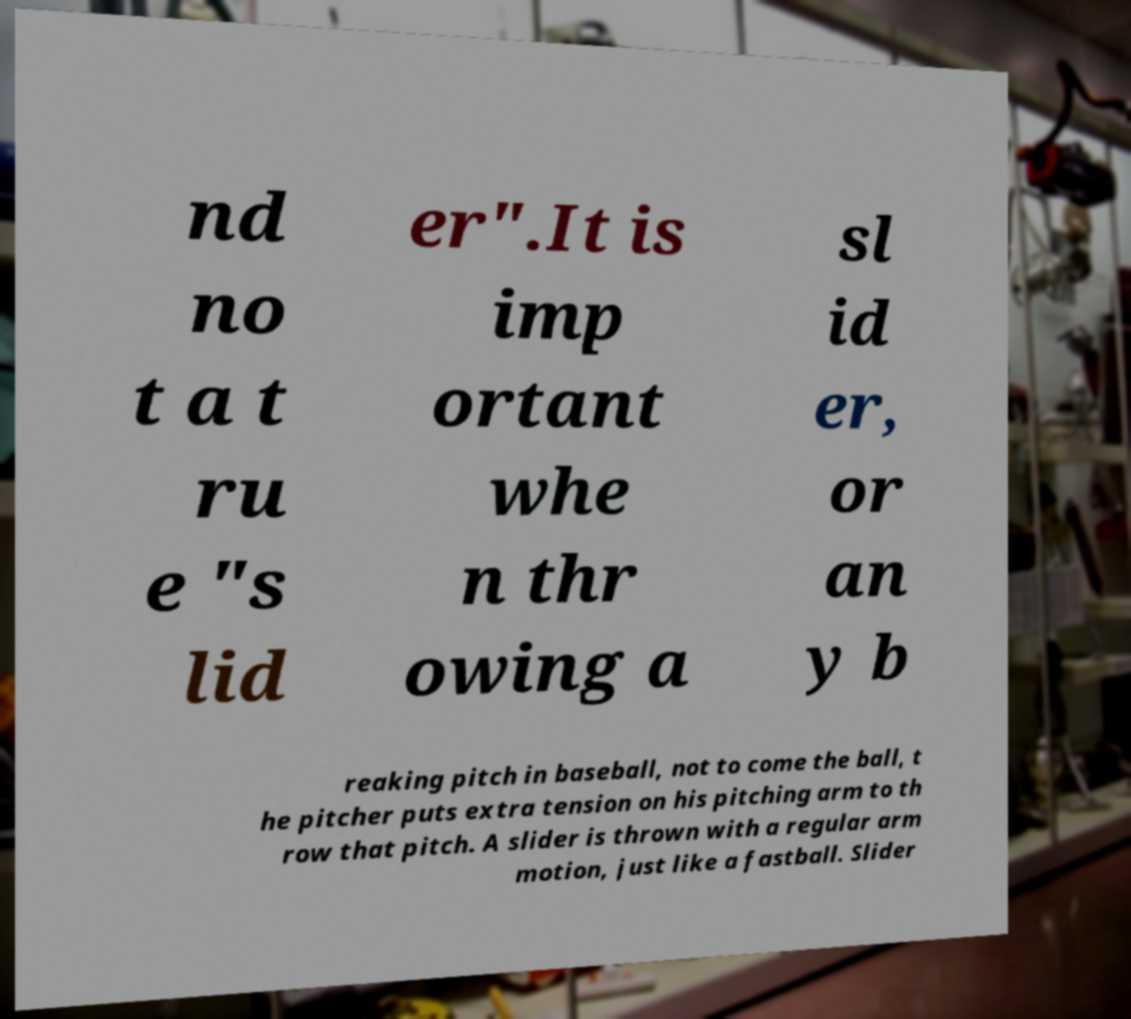I need the written content from this picture converted into text. Can you do that? nd no t a t ru e "s lid er".It is imp ortant whe n thr owing a sl id er, or an y b reaking pitch in baseball, not to come the ball, t he pitcher puts extra tension on his pitching arm to th row that pitch. A slider is thrown with a regular arm motion, just like a fastball. Slider 